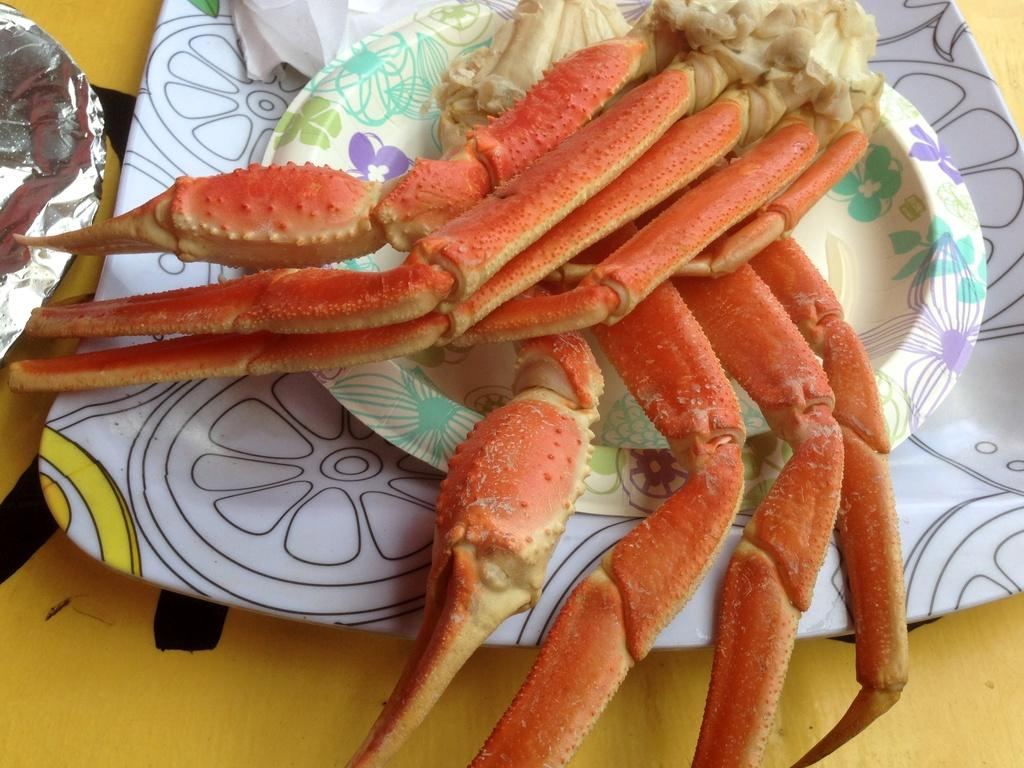What is on the plate that is visible in the image? There is a plate with food in the image. Are there any other plates on the table? Yes, there are other plates on the table. What item can be seen for wiping or blowing one's nose in the image? There is a tissue in the image. What stage of development is the fire shown in the image? There is no fire present in the image. 